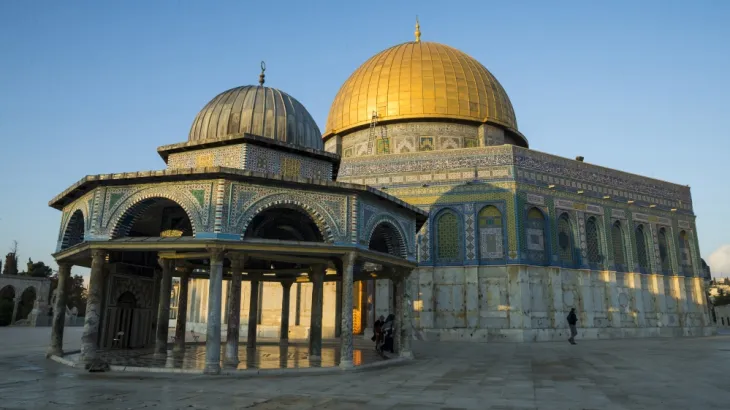Can you tell me more about the historical significance of the Al Aqsa Mosque? Certainly! The Al Aqsa Mosque holds a venerable place in Islamic history, believed to be the third holiest site in Islam. Located in the Old City of Jerusalem, it spans approximately 14 hectares and is part of the larger compound known as the Haram esh-Sharif, or the Noble Sanctuary. The site is traditionally regarded as the place where Muhammad ascended to heaven during the Night Journey. Over the centuries, it has been a focal point for numerous historical events and remains a symbol of faith and endurance amidst regional disputes. 